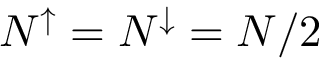<formula> <loc_0><loc_0><loc_500><loc_500>N ^ { \uparrow } = N ^ { \downarrow } = N / 2</formula> 